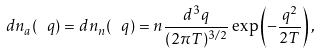<formula> <loc_0><loc_0><loc_500><loc_500>d n _ { a } ( \ q ) = d n _ { n } ( \ q ) = n \frac { d ^ { 3 } q } { ( 2 \pi T ) ^ { 3 / 2 } } \exp \left ( - \frac { q ^ { 2 } } { 2 T } \right ) ,</formula> 